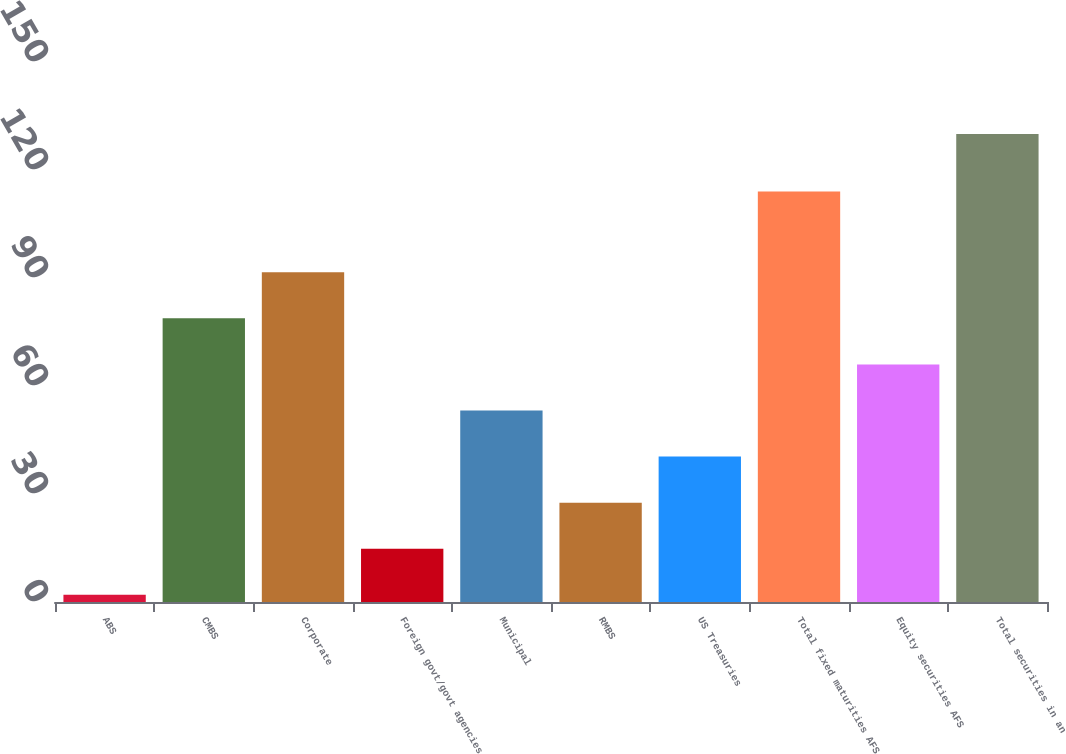Convert chart. <chart><loc_0><loc_0><loc_500><loc_500><bar_chart><fcel>ABS<fcel>CMBS<fcel>Corporate<fcel>Foreign govt/govt agencies<fcel>Municipal<fcel>RMBS<fcel>US Treasuries<fcel>Total fixed maturities AFS<fcel>Equity securities AFS<fcel>Total securities in an<nl><fcel>2<fcel>78.8<fcel>91.6<fcel>14.8<fcel>53.2<fcel>27.6<fcel>40.4<fcel>114<fcel>66<fcel>130<nl></chart> 